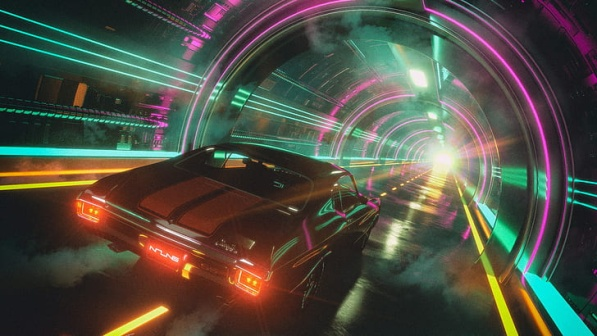Can you describe the main features of this image for me? The image presents a dynamic scene set in a futuristic city. At the center of the composition, a sleek black sports car with glowing red taillights is in motion. The car is driving on a road marked with yellow lines, suggesting a sense of direction and movement.

The car is navigating through a tunnel, which is characterized by its unique design of arches illuminated with vibrant blue and pink neon lights. These lights cast a glow on the scene, adding to the futuristic ambiance.

Beyond the tunnel, the background reveals a cityscape with towering buildings, hinting at an urban setting. The cityscape is somewhat blurred, suggesting it's at a distance. A bright white light at the end of the tunnel stands out, possibly indicating the exit of the tunnel or a source of illumination in the city.

Overall, the image captures a moment of the car's journey through this neon-lit tunnel in a futuristic cityscape. The precise locations of objects, their actions, and the interplay of light and color all contribute to the narrative of the image. The image does not contain any discernible text. The relative positions of the objects, such as the car being inside the tunnel and the cityscape being in the background, are accurately represented. 